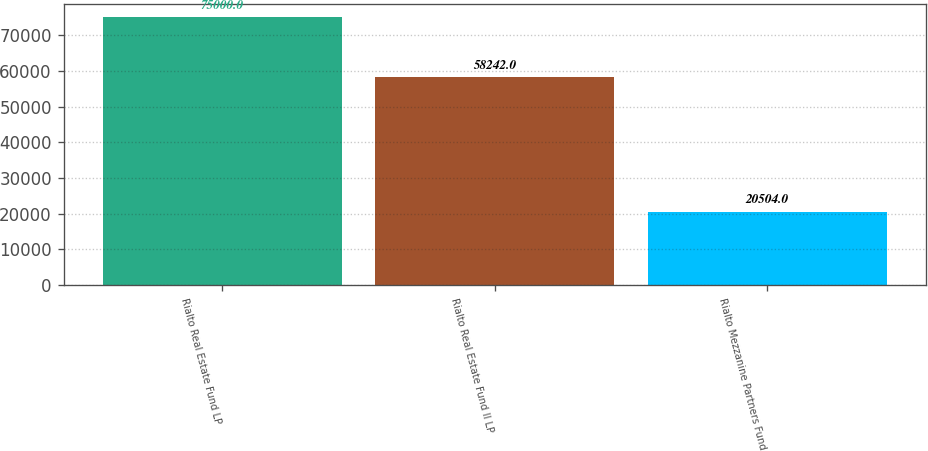Convert chart to OTSL. <chart><loc_0><loc_0><loc_500><loc_500><bar_chart><fcel>Rialto Real Estate Fund LP<fcel>Rialto Real Estate Fund II LP<fcel>Rialto Mezzanine Partners Fund<nl><fcel>75000<fcel>58242<fcel>20504<nl></chart> 